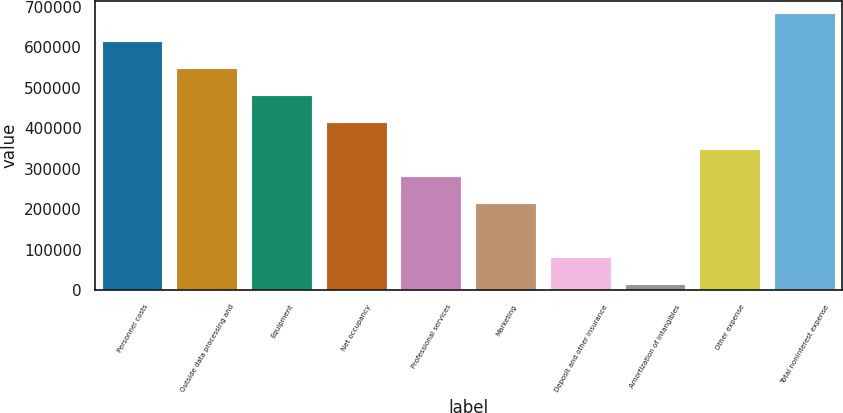Convert chart to OTSL. <chart><loc_0><loc_0><loc_500><loc_500><bar_chart><fcel>Personnel costs<fcel>Outside data processing and<fcel>Equipment<fcel>Net occupancy<fcel>Professional services<fcel>Marketing<fcel>Deposit and other insurance<fcel>Amortization of intangibles<fcel>Other expense<fcel>Total noninterest expense<nl><fcel>614757<fcel>548017<fcel>481278<fcel>414538<fcel>281058<fcel>214318<fcel>80838.8<fcel>14099<fcel>347798<fcel>681497<nl></chart> 